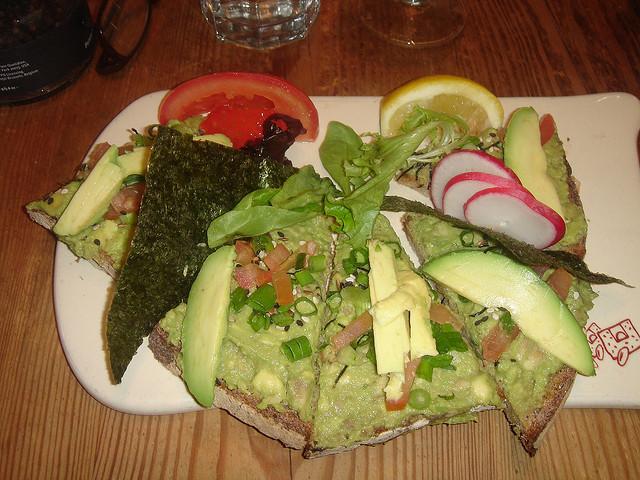What is the red food called?
Give a very brief answer. Tomato. Does this look like a healthy meal?
Concise answer only. Yes. What is the table top made of?
Quick response, please. Wood. 